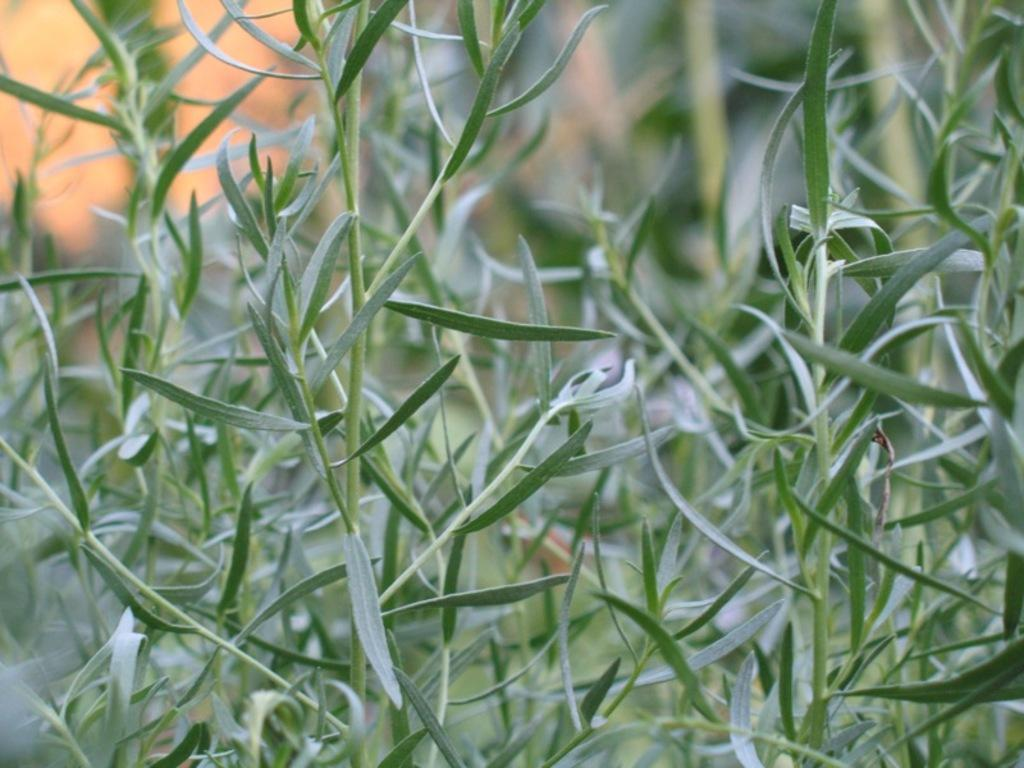What type of living organisms can be seen in the image? Plants can be seen in the image. Can you describe the background of the image? The background of the image is blurred. What word is written on the faucet in the image? There is no faucet present in the image, so it is not possible to answer that question. 